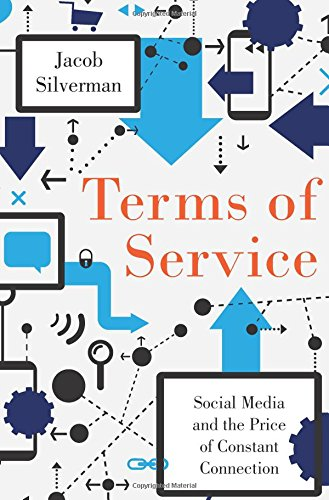Who is the author of this book?
Answer the question using a single word or phrase. Jacob Silverman What is the title of this book? Terms of Service: Social Media and the Price of Constant Connection What is the genre of this book? Computers & Technology Is this book related to Computers & Technology? Yes Is this book related to Mystery, Thriller & Suspense? No 